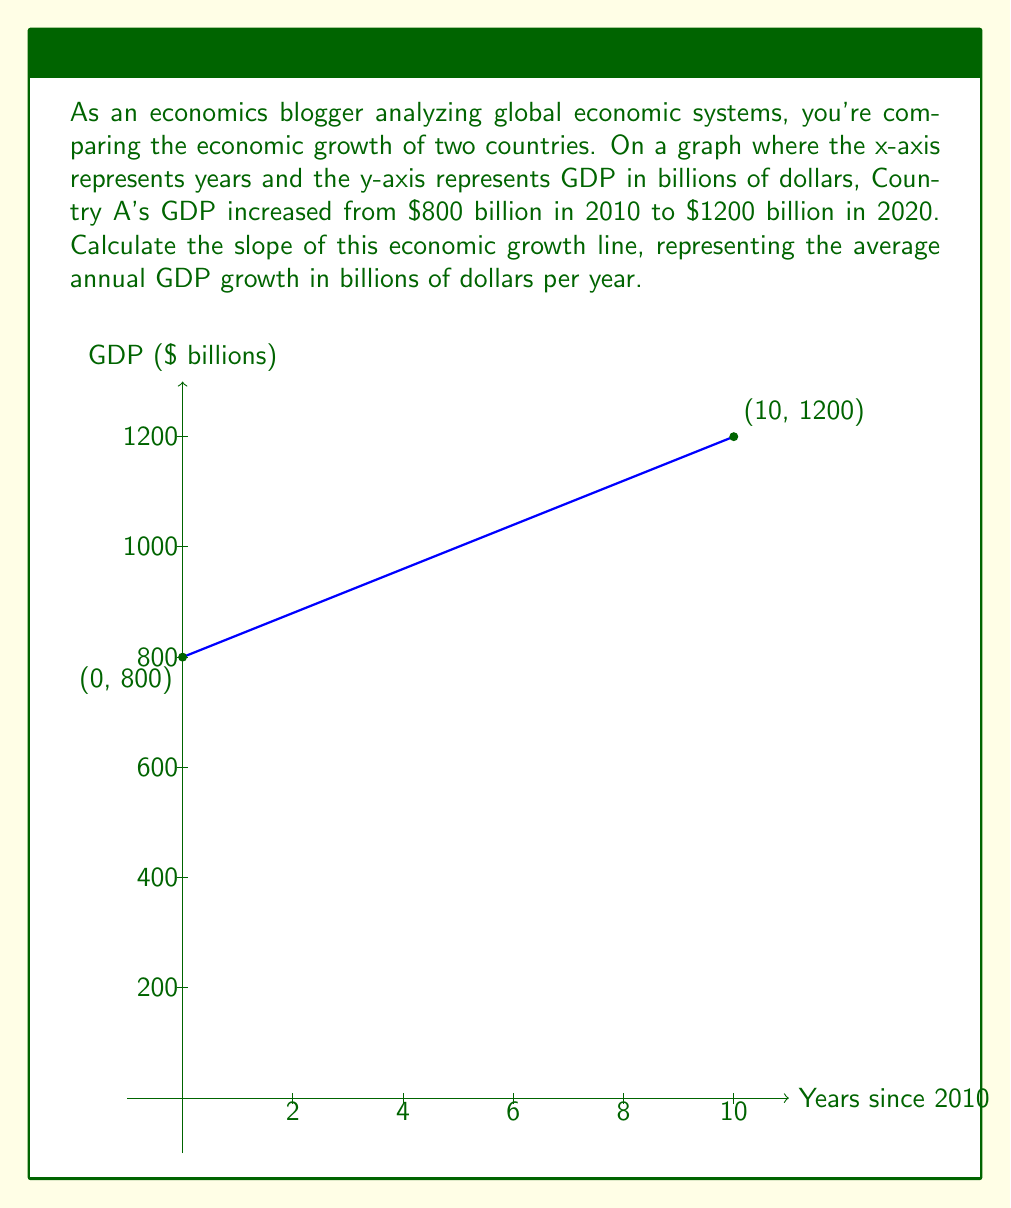Teach me how to tackle this problem. To calculate the slope of the economic growth line, we need to use the slope formula:

$$ \text{Slope} = \frac{\text{Change in y}}{\text{Change in x}} = \frac{\Delta y}{\Delta x} $$

Let's identify our points:
- Point 1: (0, 800) representing 2010
- Point 2: (10, 1200) representing 2020

Now, let's calculate the change in x and y:

$\Delta x = 10 - 0 = 10$ years
$\Delta y = 1200 - 800 = 400$ billion dollars

Plugging these values into our slope formula:

$$ \text{Slope} = \frac{400}{10} = 40 $$

Therefore, the slope of the economic growth line is 40 billion dollars per year. This represents the average annual increase in GDP over the 10-year period from 2010 to 2020.
Answer: $40 billion/year 